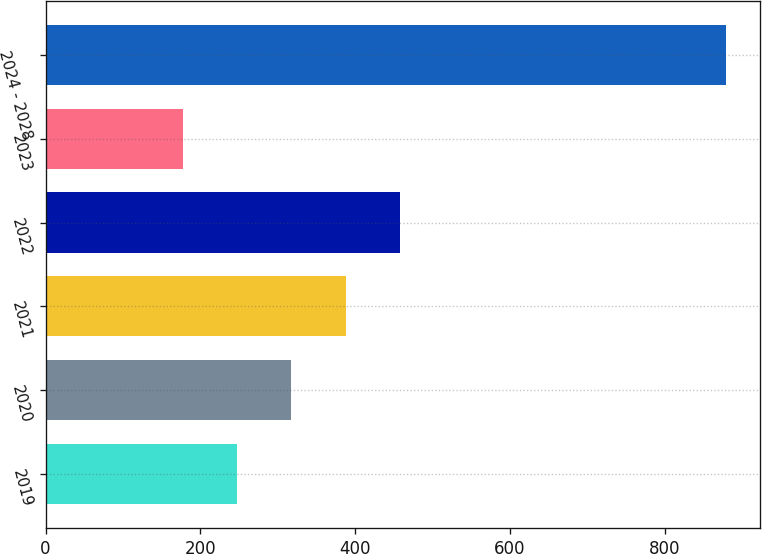<chart> <loc_0><loc_0><loc_500><loc_500><bar_chart><fcel>2019<fcel>2020<fcel>2021<fcel>2022<fcel>2023<fcel>2024 - 2028<nl><fcel>247.2<fcel>317.4<fcel>387.6<fcel>457.8<fcel>177<fcel>879<nl></chart> 